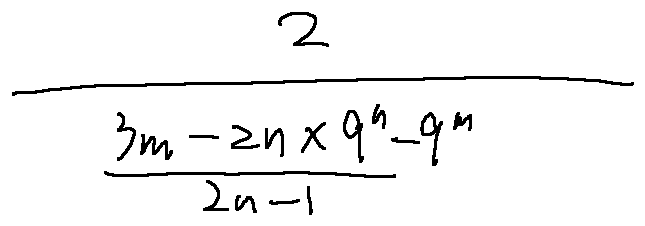<formula> <loc_0><loc_0><loc_500><loc_500>\frac { 2 } { \frac { 3 m - 2 n \times 9 ^ { n } - 9 ^ { m } } { 2 n - 1 } }</formula> 